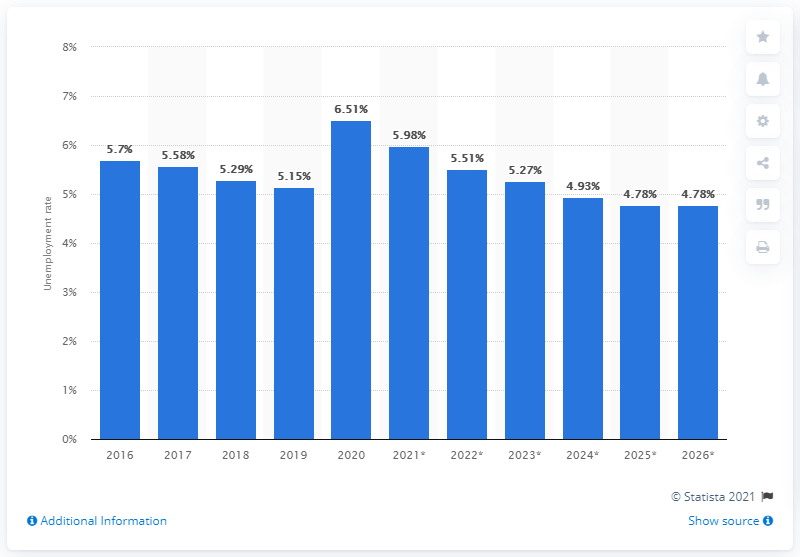Give some essential details in this illustration. The unemployment rate in Australia ended in 2020. 